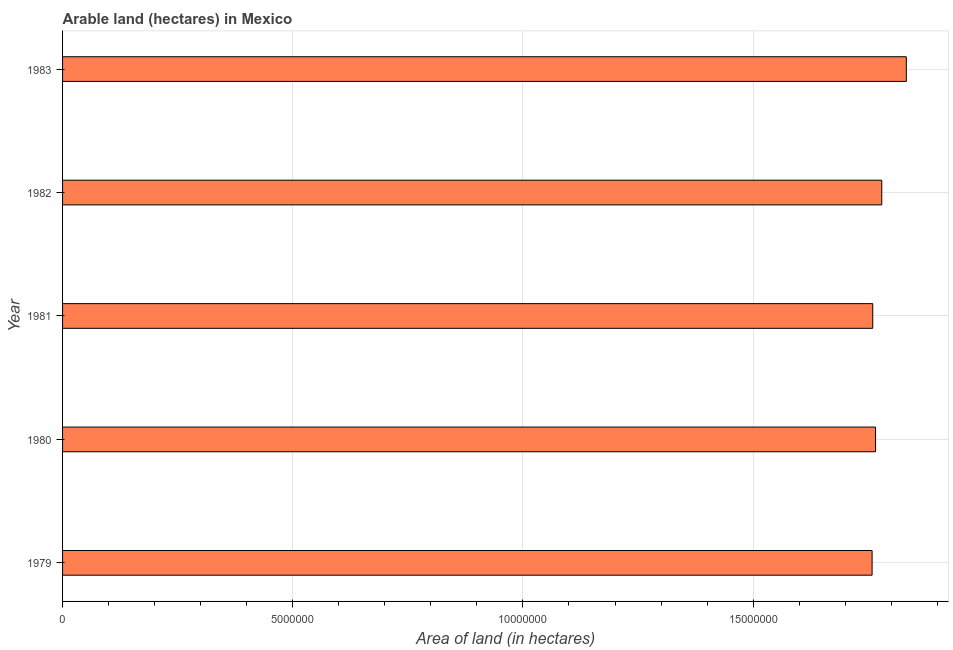Does the graph contain grids?
Give a very brief answer. Yes. What is the title of the graph?
Provide a succinct answer. Arable land (hectares) in Mexico. What is the label or title of the X-axis?
Offer a terse response. Area of land (in hectares). What is the area of land in 1983?
Ensure brevity in your answer.  1.83e+07. Across all years, what is the maximum area of land?
Make the answer very short. 1.83e+07. Across all years, what is the minimum area of land?
Provide a succinct answer. 1.76e+07. In which year was the area of land maximum?
Offer a very short reply. 1983. In which year was the area of land minimum?
Your answer should be compact. 1979. What is the sum of the area of land?
Offer a terse response. 8.90e+07. What is the difference between the area of land in 1982 and 1983?
Your answer should be compact. -5.33e+05. What is the average area of land per year?
Give a very brief answer. 1.78e+07. What is the median area of land?
Make the answer very short. 1.77e+07. In how many years, is the area of land greater than 4000000 hectares?
Provide a short and direct response. 5. What is the ratio of the area of land in 1979 to that in 1981?
Your response must be concise. 1. Is the area of land in 1981 less than that in 1983?
Make the answer very short. Yes. What is the difference between the highest and the second highest area of land?
Ensure brevity in your answer.  5.33e+05. Is the sum of the area of land in 1979 and 1982 greater than the maximum area of land across all years?
Offer a very short reply. Yes. What is the difference between the highest and the lowest area of land?
Your answer should be very brief. 7.43e+05. How many years are there in the graph?
Your answer should be very brief. 5. What is the difference between two consecutive major ticks on the X-axis?
Your answer should be very brief. 5.00e+06. What is the Area of land (in hectares) in 1979?
Provide a succinct answer. 1.76e+07. What is the Area of land (in hectares) in 1980?
Your answer should be very brief. 1.77e+07. What is the Area of land (in hectares) of 1981?
Make the answer very short. 1.76e+07. What is the Area of land (in hectares) in 1982?
Your answer should be very brief. 1.78e+07. What is the Area of land (in hectares) of 1983?
Give a very brief answer. 1.83e+07. What is the difference between the Area of land (in hectares) in 1979 and 1980?
Provide a short and direct response. -7.50e+04. What is the difference between the Area of land (in hectares) in 1979 and 1981?
Provide a short and direct response. -1.40e+04. What is the difference between the Area of land (in hectares) in 1979 and 1983?
Your response must be concise. -7.43e+05. What is the difference between the Area of land (in hectares) in 1980 and 1981?
Provide a succinct answer. 6.10e+04. What is the difference between the Area of land (in hectares) in 1980 and 1982?
Give a very brief answer. -1.35e+05. What is the difference between the Area of land (in hectares) in 1980 and 1983?
Offer a terse response. -6.68e+05. What is the difference between the Area of land (in hectares) in 1981 and 1982?
Ensure brevity in your answer.  -1.96e+05. What is the difference between the Area of land (in hectares) in 1981 and 1983?
Provide a succinct answer. -7.29e+05. What is the difference between the Area of land (in hectares) in 1982 and 1983?
Provide a short and direct response. -5.33e+05. What is the ratio of the Area of land (in hectares) in 1980 to that in 1982?
Provide a short and direct response. 0.99. What is the ratio of the Area of land (in hectares) in 1980 to that in 1983?
Your answer should be very brief. 0.96. What is the ratio of the Area of land (in hectares) in 1981 to that in 1982?
Offer a very short reply. 0.99. 